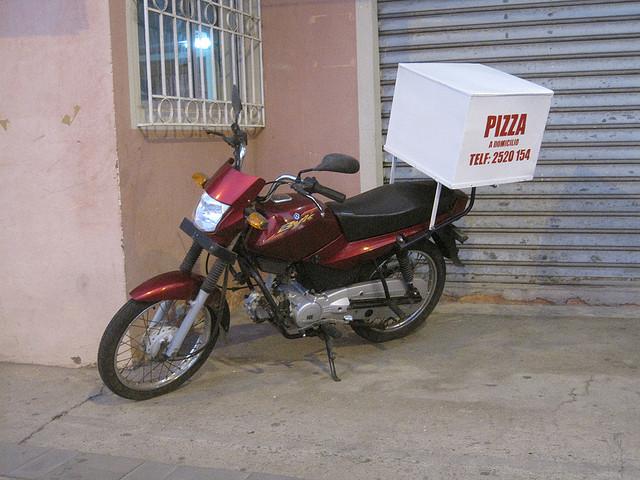Don't you think the pizza would be cold by the time it was delivered?
Be succinct. No. What kind of number is on the motorcycle?
Concise answer only. Telephone. What kind of bike is in the picture?
Answer briefly. Motorcycle. 